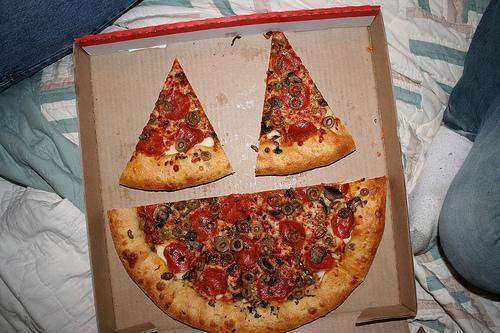How many slices are at the top of the box?
Give a very brief answer. 2. 